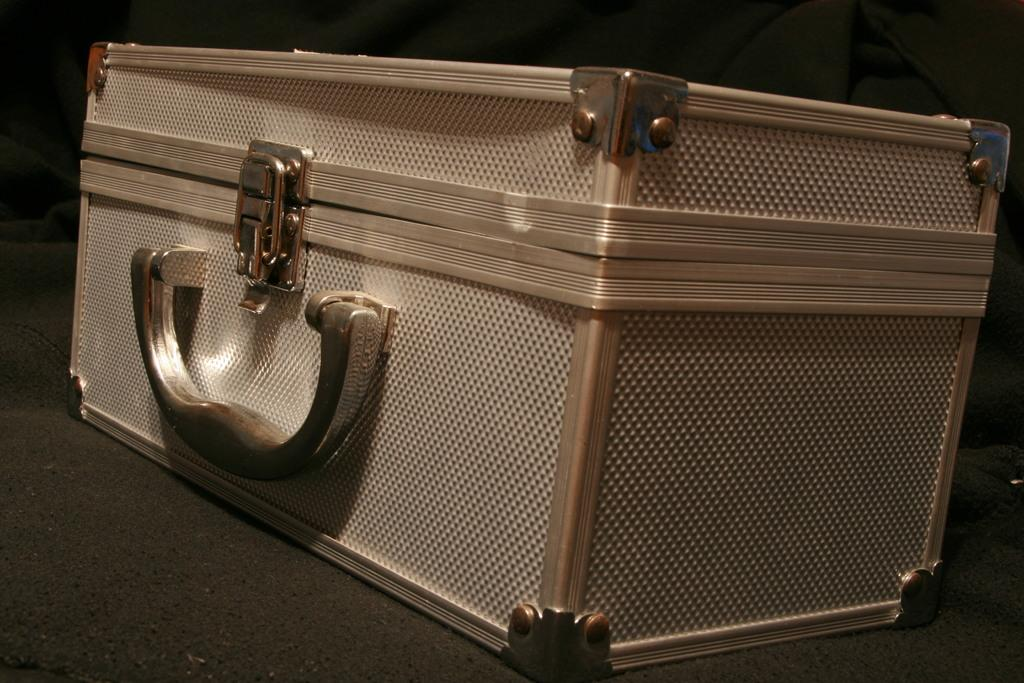What is the color of the box in the image? The box is silver-colored. What are some features of the box? The box has screws, a handle, and a lock. Where is the box located in the image? The box is placed on the floor. What type of ink is used to write on the notebook in the image? There is no notebook present in the image, so it is not possible to determine the type of ink used. 